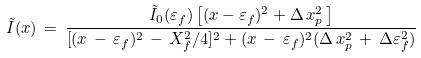Convert formula to latex. <formula><loc_0><loc_0><loc_500><loc_500>\tilde { I } ( x ) \, = \, \frac { \tilde { I } _ { 0 } ( \varepsilon _ { f } ) \left [ ( x - \varepsilon _ { f } ) ^ { 2 } + \Delta \, x _ { p } ^ { 2 } \, \right ] } { [ ( x \, - \, \varepsilon _ { f } ) ^ { 2 } \, - \, X _ { f } ^ { 2 } / 4 ] ^ { 2 } + ( x \, - \, \varepsilon _ { f } ) ^ { 2 } ( \Delta \, x _ { p } ^ { 2 } \, + \, \Delta \varepsilon _ { f } ^ { 2 } ) }</formula> 